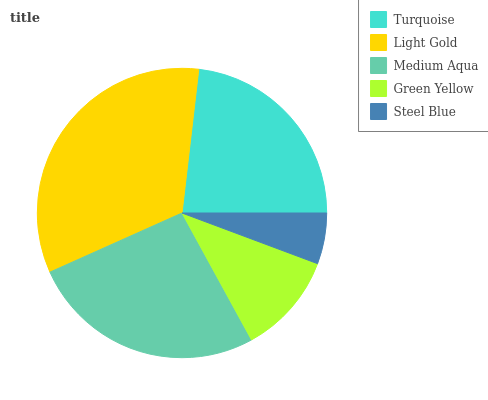Is Steel Blue the minimum?
Answer yes or no. Yes. Is Light Gold the maximum?
Answer yes or no. Yes. Is Medium Aqua the minimum?
Answer yes or no. No. Is Medium Aqua the maximum?
Answer yes or no. No. Is Light Gold greater than Medium Aqua?
Answer yes or no. Yes. Is Medium Aqua less than Light Gold?
Answer yes or no. Yes. Is Medium Aqua greater than Light Gold?
Answer yes or no. No. Is Light Gold less than Medium Aqua?
Answer yes or no. No. Is Turquoise the high median?
Answer yes or no. Yes. Is Turquoise the low median?
Answer yes or no. Yes. Is Medium Aqua the high median?
Answer yes or no. No. Is Light Gold the low median?
Answer yes or no. No. 